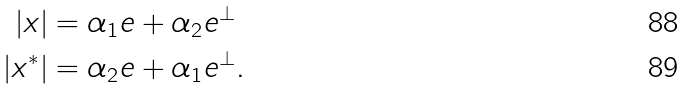<formula> <loc_0><loc_0><loc_500><loc_500>| x | & = \alpha _ { 1 } e + \alpha _ { 2 } e ^ { \bot } \\ | x ^ { * } | & = \alpha _ { 2 } e + \alpha _ { 1 } e ^ { \bot } .</formula> 